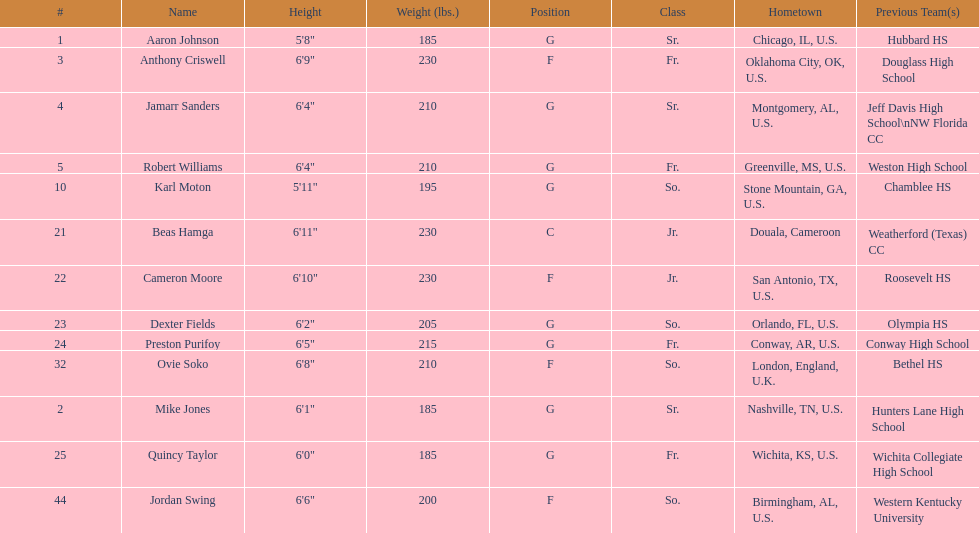What is the average weight of jamarr sanders and robert williams? 210. 